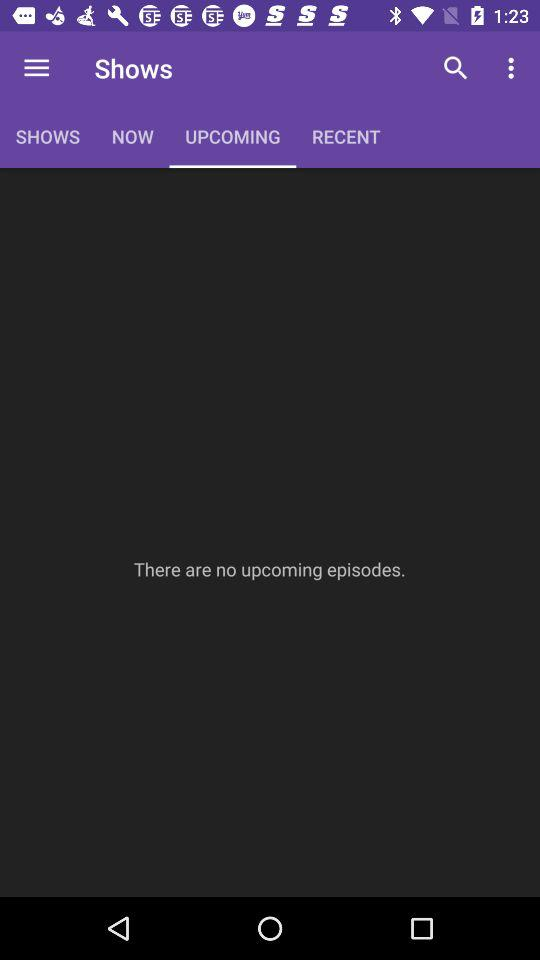Which tab is selected? The selected tab is "UPCOMING". 